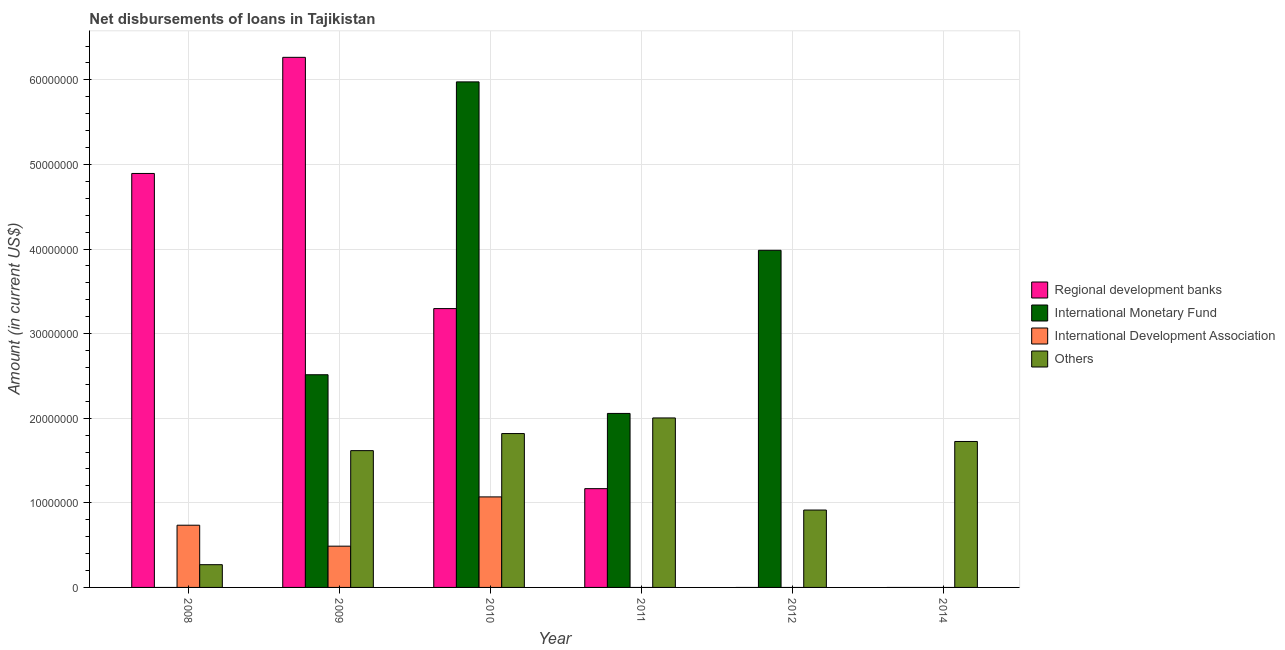How many bars are there on the 3rd tick from the left?
Your answer should be compact. 4. In how many cases, is the number of bars for a given year not equal to the number of legend labels?
Your response must be concise. 4. What is the amount of loan disimbursed by international development association in 2009?
Keep it short and to the point. 4.88e+06. Across all years, what is the maximum amount of loan disimbursed by other organisations?
Give a very brief answer. 2.00e+07. Across all years, what is the minimum amount of loan disimbursed by regional development banks?
Make the answer very short. 0. What is the total amount of loan disimbursed by international monetary fund in the graph?
Your answer should be very brief. 1.45e+08. What is the difference between the amount of loan disimbursed by international development association in 2008 and that in 2009?
Give a very brief answer. 2.48e+06. What is the difference between the amount of loan disimbursed by international monetary fund in 2008 and the amount of loan disimbursed by other organisations in 2011?
Provide a succinct answer. -2.06e+07. What is the average amount of loan disimbursed by regional development banks per year?
Your answer should be very brief. 2.60e+07. What is the ratio of the amount of loan disimbursed by international development association in 2008 to that in 2009?
Offer a terse response. 1.51. Is the difference between the amount of loan disimbursed by other organisations in 2009 and 2014 greater than the difference between the amount of loan disimbursed by regional development banks in 2009 and 2014?
Provide a short and direct response. No. What is the difference between the highest and the second highest amount of loan disimbursed by international monetary fund?
Provide a short and direct response. 1.99e+07. What is the difference between the highest and the lowest amount of loan disimbursed by international development association?
Provide a succinct answer. 1.07e+07. How many years are there in the graph?
Ensure brevity in your answer.  6. Are the values on the major ticks of Y-axis written in scientific E-notation?
Make the answer very short. No. Does the graph contain any zero values?
Offer a terse response. Yes. How are the legend labels stacked?
Give a very brief answer. Vertical. What is the title of the graph?
Offer a terse response. Net disbursements of loans in Tajikistan. Does "Environmental sustainability" appear as one of the legend labels in the graph?
Your answer should be very brief. No. What is the label or title of the X-axis?
Provide a short and direct response. Year. What is the label or title of the Y-axis?
Keep it short and to the point. Amount (in current US$). What is the Amount (in current US$) in Regional development banks in 2008?
Offer a very short reply. 4.89e+07. What is the Amount (in current US$) in International Monetary Fund in 2008?
Offer a terse response. 0. What is the Amount (in current US$) of International Development Association in 2008?
Your answer should be very brief. 7.35e+06. What is the Amount (in current US$) of Others in 2008?
Ensure brevity in your answer.  2.69e+06. What is the Amount (in current US$) of Regional development banks in 2009?
Your answer should be very brief. 6.27e+07. What is the Amount (in current US$) of International Monetary Fund in 2009?
Provide a succinct answer. 2.51e+07. What is the Amount (in current US$) in International Development Association in 2009?
Your answer should be very brief. 4.88e+06. What is the Amount (in current US$) of Others in 2009?
Give a very brief answer. 1.62e+07. What is the Amount (in current US$) of Regional development banks in 2010?
Make the answer very short. 3.30e+07. What is the Amount (in current US$) of International Monetary Fund in 2010?
Give a very brief answer. 5.98e+07. What is the Amount (in current US$) in International Development Association in 2010?
Offer a very short reply. 1.07e+07. What is the Amount (in current US$) in Others in 2010?
Give a very brief answer. 1.82e+07. What is the Amount (in current US$) in Regional development banks in 2011?
Provide a short and direct response. 1.17e+07. What is the Amount (in current US$) of International Monetary Fund in 2011?
Your answer should be compact. 2.06e+07. What is the Amount (in current US$) in International Development Association in 2011?
Keep it short and to the point. 0. What is the Amount (in current US$) of Others in 2011?
Make the answer very short. 2.00e+07. What is the Amount (in current US$) of International Monetary Fund in 2012?
Ensure brevity in your answer.  3.99e+07. What is the Amount (in current US$) in International Development Association in 2012?
Offer a very short reply. 0. What is the Amount (in current US$) of Others in 2012?
Your answer should be very brief. 9.15e+06. What is the Amount (in current US$) of International Monetary Fund in 2014?
Provide a short and direct response. 0. What is the Amount (in current US$) in Others in 2014?
Make the answer very short. 1.73e+07. Across all years, what is the maximum Amount (in current US$) of Regional development banks?
Offer a very short reply. 6.27e+07. Across all years, what is the maximum Amount (in current US$) of International Monetary Fund?
Your answer should be very brief. 5.98e+07. Across all years, what is the maximum Amount (in current US$) in International Development Association?
Keep it short and to the point. 1.07e+07. Across all years, what is the maximum Amount (in current US$) of Others?
Ensure brevity in your answer.  2.00e+07. Across all years, what is the minimum Amount (in current US$) in Regional development banks?
Make the answer very short. 0. Across all years, what is the minimum Amount (in current US$) of Others?
Your answer should be compact. 2.69e+06. What is the total Amount (in current US$) of Regional development banks in the graph?
Your answer should be compact. 1.56e+08. What is the total Amount (in current US$) of International Monetary Fund in the graph?
Make the answer very short. 1.45e+08. What is the total Amount (in current US$) in International Development Association in the graph?
Your response must be concise. 2.29e+07. What is the total Amount (in current US$) in Others in the graph?
Give a very brief answer. 8.35e+07. What is the difference between the Amount (in current US$) in Regional development banks in 2008 and that in 2009?
Ensure brevity in your answer.  -1.37e+07. What is the difference between the Amount (in current US$) in International Development Association in 2008 and that in 2009?
Your response must be concise. 2.48e+06. What is the difference between the Amount (in current US$) in Others in 2008 and that in 2009?
Offer a terse response. -1.35e+07. What is the difference between the Amount (in current US$) in Regional development banks in 2008 and that in 2010?
Make the answer very short. 1.60e+07. What is the difference between the Amount (in current US$) in International Development Association in 2008 and that in 2010?
Ensure brevity in your answer.  -3.35e+06. What is the difference between the Amount (in current US$) in Others in 2008 and that in 2010?
Your answer should be compact. -1.55e+07. What is the difference between the Amount (in current US$) in Regional development banks in 2008 and that in 2011?
Give a very brief answer. 3.73e+07. What is the difference between the Amount (in current US$) of Others in 2008 and that in 2011?
Offer a very short reply. -1.73e+07. What is the difference between the Amount (in current US$) in Others in 2008 and that in 2012?
Your answer should be very brief. -6.46e+06. What is the difference between the Amount (in current US$) of Others in 2008 and that in 2014?
Your answer should be very brief. -1.46e+07. What is the difference between the Amount (in current US$) in Regional development banks in 2009 and that in 2010?
Offer a terse response. 2.97e+07. What is the difference between the Amount (in current US$) of International Monetary Fund in 2009 and that in 2010?
Your answer should be very brief. -3.46e+07. What is the difference between the Amount (in current US$) in International Development Association in 2009 and that in 2010?
Your response must be concise. -5.82e+06. What is the difference between the Amount (in current US$) of Others in 2009 and that in 2010?
Your response must be concise. -2.02e+06. What is the difference between the Amount (in current US$) in Regional development banks in 2009 and that in 2011?
Your answer should be compact. 5.10e+07. What is the difference between the Amount (in current US$) of International Monetary Fund in 2009 and that in 2011?
Give a very brief answer. 4.57e+06. What is the difference between the Amount (in current US$) in Others in 2009 and that in 2011?
Offer a terse response. -3.86e+06. What is the difference between the Amount (in current US$) of International Monetary Fund in 2009 and that in 2012?
Make the answer very short. -1.47e+07. What is the difference between the Amount (in current US$) in Others in 2009 and that in 2012?
Offer a very short reply. 7.02e+06. What is the difference between the Amount (in current US$) of Others in 2009 and that in 2014?
Provide a succinct answer. -1.08e+06. What is the difference between the Amount (in current US$) of Regional development banks in 2010 and that in 2011?
Keep it short and to the point. 2.13e+07. What is the difference between the Amount (in current US$) in International Monetary Fund in 2010 and that in 2011?
Keep it short and to the point. 3.92e+07. What is the difference between the Amount (in current US$) of Others in 2010 and that in 2011?
Provide a short and direct response. -1.84e+06. What is the difference between the Amount (in current US$) in International Monetary Fund in 2010 and that in 2012?
Ensure brevity in your answer.  1.99e+07. What is the difference between the Amount (in current US$) in Others in 2010 and that in 2012?
Offer a terse response. 9.04e+06. What is the difference between the Amount (in current US$) of Others in 2010 and that in 2014?
Offer a terse response. 9.37e+05. What is the difference between the Amount (in current US$) in International Monetary Fund in 2011 and that in 2012?
Provide a short and direct response. -1.93e+07. What is the difference between the Amount (in current US$) of Others in 2011 and that in 2012?
Make the answer very short. 1.09e+07. What is the difference between the Amount (in current US$) of Others in 2011 and that in 2014?
Provide a succinct answer. 2.78e+06. What is the difference between the Amount (in current US$) in Others in 2012 and that in 2014?
Ensure brevity in your answer.  -8.10e+06. What is the difference between the Amount (in current US$) of Regional development banks in 2008 and the Amount (in current US$) of International Monetary Fund in 2009?
Provide a succinct answer. 2.38e+07. What is the difference between the Amount (in current US$) of Regional development banks in 2008 and the Amount (in current US$) of International Development Association in 2009?
Offer a terse response. 4.41e+07. What is the difference between the Amount (in current US$) of Regional development banks in 2008 and the Amount (in current US$) of Others in 2009?
Offer a terse response. 3.28e+07. What is the difference between the Amount (in current US$) in International Development Association in 2008 and the Amount (in current US$) in Others in 2009?
Offer a very short reply. -8.82e+06. What is the difference between the Amount (in current US$) in Regional development banks in 2008 and the Amount (in current US$) in International Monetary Fund in 2010?
Keep it short and to the point. -1.08e+07. What is the difference between the Amount (in current US$) in Regional development banks in 2008 and the Amount (in current US$) in International Development Association in 2010?
Your answer should be very brief. 3.82e+07. What is the difference between the Amount (in current US$) in Regional development banks in 2008 and the Amount (in current US$) in Others in 2010?
Keep it short and to the point. 3.07e+07. What is the difference between the Amount (in current US$) in International Development Association in 2008 and the Amount (in current US$) in Others in 2010?
Offer a terse response. -1.08e+07. What is the difference between the Amount (in current US$) of Regional development banks in 2008 and the Amount (in current US$) of International Monetary Fund in 2011?
Provide a succinct answer. 2.84e+07. What is the difference between the Amount (in current US$) in Regional development banks in 2008 and the Amount (in current US$) in Others in 2011?
Make the answer very short. 2.89e+07. What is the difference between the Amount (in current US$) in International Development Association in 2008 and the Amount (in current US$) in Others in 2011?
Keep it short and to the point. -1.27e+07. What is the difference between the Amount (in current US$) of Regional development banks in 2008 and the Amount (in current US$) of International Monetary Fund in 2012?
Ensure brevity in your answer.  9.08e+06. What is the difference between the Amount (in current US$) of Regional development banks in 2008 and the Amount (in current US$) of Others in 2012?
Ensure brevity in your answer.  3.98e+07. What is the difference between the Amount (in current US$) of International Development Association in 2008 and the Amount (in current US$) of Others in 2012?
Keep it short and to the point. -1.80e+06. What is the difference between the Amount (in current US$) in Regional development banks in 2008 and the Amount (in current US$) in Others in 2014?
Provide a short and direct response. 3.17e+07. What is the difference between the Amount (in current US$) of International Development Association in 2008 and the Amount (in current US$) of Others in 2014?
Offer a terse response. -9.90e+06. What is the difference between the Amount (in current US$) of Regional development banks in 2009 and the Amount (in current US$) of International Monetary Fund in 2010?
Your answer should be very brief. 2.90e+06. What is the difference between the Amount (in current US$) in Regional development banks in 2009 and the Amount (in current US$) in International Development Association in 2010?
Keep it short and to the point. 5.20e+07. What is the difference between the Amount (in current US$) in Regional development banks in 2009 and the Amount (in current US$) in Others in 2010?
Provide a short and direct response. 4.45e+07. What is the difference between the Amount (in current US$) of International Monetary Fund in 2009 and the Amount (in current US$) of International Development Association in 2010?
Ensure brevity in your answer.  1.44e+07. What is the difference between the Amount (in current US$) of International Monetary Fund in 2009 and the Amount (in current US$) of Others in 2010?
Your answer should be compact. 6.95e+06. What is the difference between the Amount (in current US$) of International Development Association in 2009 and the Amount (in current US$) of Others in 2010?
Your response must be concise. -1.33e+07. What is the difference between the Amount (in current US$) of Regional development banks in 2009 and the Amount (in current US$) of International Monetary Fund in 2011?
Keep it short and to the point. 4.21e+07. What is the difference between the Amount (in current US$) in Regional development banks in 2009 and the Amount (in current US$) in Others in 2011?
Your answer should be very brief. 4.26e+07. What is the difference between the Amount (in current US$) in International Monetary Fund in 2009 and the Amount (in current US$) in Others in 2011?
Offer a terse response. 5.11e+06. What is the difference between the Amount (in current US$) in International Development Association in 2009 and the Amount (in current US$) in Others in 2011?
Ensure brevity in your answer.  -1.52e+07. What is the difference between the Amount (in current US$) of Regional development banks in 2009 and the Amount (in current US$) of International Monetary Fund in 2012?
Provide a short and direct response. 2.28e+07. What is the difference between the Amount (in current US$) in Regional development banks in 2009 and the Amount (in current US$) in Others in 2012?
Your response must be concise. 5.35e+07. What is the difference between the Amount (in current US$) in International Monetary Fund in 2009 and the Amount (in current US$) in Others in 2012?
Your answer should be compact. 1.60e+07. What is the difference between the Amount (in current US$) of International Development Association in 2009 and the Amount (in current US$) of Others in 2012?
Your response must be concise. -4.27e+06. What is the difference between the Amount (in current US$) of Regional development banks in 2009 and the Amount (in current US$) of Others in 2014?
Offer a terse response. 4.54e+07. What is the difference between the Amount (in current US$) in International Monetary Fund in 2009 and the Amount (in current US$) in Others in 2014?
Offer a terse response. 7.89e+06. What is the difference between the Amount (in current US$) in International Development Association in 2009 and the Amount (in current US$) in Others in 2014?
Provide a succinct answer. -1.24e+07. What is the difference between the Amount (in current US$) in Regional development banks in 2010 and the Amount (in current US$) in International Monetary Fund in 2011?
Your response must be concise. 1.24e+07. What is the difference between the Amount (in current US$) of Regional development banks in 2010 and the Amount (in current US$) of Others in 2011?
Your answer should be very brief. 1.29e+07. What is the difference between the Amount (in current US$) in International Monetary Fund in 2010 and the Amount (in current US$) in Others in 2011?
Make the answer very short. 3.97e+07. What is the difference between the Amount (in current US$) in International Development Association in 2010 and the Amount (in current US$) in Others in 2011?
Your answer should be compact. -9.33e+06. What is the difference between the Amount (in current US$) in Regional development banks in 2010 and the Amount (in current US$) in International Monetary Fund in 2012?
Offer a terse response. -6.89e+06. What is the difference between the Amount (in current US$) of Regional development banks in 2010 and the Amount (in current US$) of Others in 2012?
Provide a short and direct response. 2.38e+07. What is the difference between the Amount (in current US$) of International Monetary Fund in 2010 and the Amount (in current US$) of Others in 2012?
Provide a short and direct response. 5.06e+07. What is the difference between the Amount (in current US$) of International Development Association in 2010 and the Amount (in current US$) of Others in 2012?
Your answer should be very brief. 1.55e+06. What is the difference between the Amount (in current US$) in Regional development banks in 2010 and the Amount (in current US$) in Others in 2014?
Your response must be concise. 1.57e+07. What is the difference between the Amount (in current US$) of International Monetary Fund in 2010 and the Amount (in current US$) of Others in 2014?
Your answer should be compact. 4.25e+07. What is the difference between the Amount (in current US$) of International Development Association in 2010 and the Amount (in current US$) of Others in 2014?
Your response must be concise. -6.55e+06. What is the difference between the Amount (in current US$) of Regional development banks in 2011 and the Amount (in current US$) of International Monetary Fund in 2012?
Your response must be concise. -2.82e+07. What is the difference between the Amount (in current US$) in Regional development banks in 2011 and the Amount (in current US$) in Others in 2012?
Give a very brief answer. 2.53e+06. What is the difference between the Amount (in current US$) in International Monetary Fund in 2011 and the Amount (in current US$) in Others in 2012?
Your answer should be compact. 1.14e+07. What is the difference between the Amount (in current US$) in Regional development banks in 2011 and the Amount (in current US$) in Others in 2014?
Give a very brief answer. -5.58e+06. What is the difference between the Amount (in current US$) of International Monetary Fund in 2011 and the Amount (in current US$) of Others in 2014?
Keep it short and to the point. 3.32e+06. What is the difference between the Amount (in current US$) in International Monetary Fund in 2012 and the Amount (in current US$) in Others in 2014?
Give a very brief answer. 2.26e+07. What is the average Amount (in current US$) of Regional development banks per year?
Ensure brevity in your answer.  2.60e+07. What is the average Amount (in current US$) in International Monetary Fund per year?
Ensure brevity in your answer.  2.42e+07. What is the average Amount (in current US$) in International Development Association per year?
Give a very brief answer. 3.82e+06. What is the average Amount (in current US$) of Others per year?
Ensure brevity in your answer.  1.39e+07. In the year 2008, what is the difference between the Amount (in current US$) of Regional development banks and Amount (in current US$) of International Development Association?
Provide a succinct answer. 4.16e+07. In the year 2008, what is the difference between the Amount (in current US$) in Regional development banks and Amount (in current US$) in Others?
Your answer should be compact. 4.62e+07. In the year 2008, what is the difference between the Amount (in current US$) of International Development Association and Amount (in current US$) of Others?
Keep it short and to the point. 4.66e+06. In the year 2009, what is the difference between the Amount (in current US$) of Regional development banks and Amount (in current US$) of International Monetary Fund?
Make the answer very short. 3.75e+07. In the year 2009, what is the difference between the Amount (in current US$) of Regional development banks and Amount (in current US$) of International Development Association?
Ensure brevity in your answer.  5.78e+07. In the year 2009, what is the difference between the Amount (in current US$) of Regional development banks and Amount (in current US$) of Others?
Make the answer very short. 4.65e+07. In the year 2009, what is the difference between the Amount (in current US$) in International Monetary Fund and Amount (in current US$) in International Development Association?
Give a very brief answer. 2.03e+07. In the year 2009, what is the difference between the Amount (in current US$) in International Monetary Fund and Amount (in current US$) in Others?
Your answer should be very brief. 8.97e+06. In the year 2009, what is the difference between the Amount (in current US$) in International Development Association and Amount (in current US$) in Others?
Keep it short and to the point. -1.13e+07. In the year 2010, what is the difference between the Amount (in current US$) in Regional development banks and Amount (in current US$) in International Monetary Fund?
Ensure brevity in your answer.  -2.68e+07. In the year 2010, what is the difference between the Amount (in current US$) in Regional development banks and Amount (in current US$) in International Development Association?
Give a very brief answer. 2.23e+07. In the year 2010, what is the difference between the Amount (in current US$) in Regional development banks and Amount (in current US$) in Others?
Give a very brief answer. 1.48e+07. In the year 2010, what is the difference between the Amount (in current US$) in International Monetary Fund and Amount (in current US$) in International Development Association?
Make the answer very short. 4.91e+07. In the year 2010, what is the difference between the Amount (in current US$) in International Monetary Fund and Amount (in current US$) in Others?
Provide a short and direct response. 4.16e+07. In the year 2010, what is the difference between the Amount (in current US$) of International Development Association and Amount (in current US$) of Others?
Offer a very short reply. -7.49e+06. In the year 2011, what is the difference between the Amount (in current US$) of Regional development banks and Amount (in current US$) of International Monetary Fund?
Your answer should be very brief. -8.89e+06. In the year 2011, what is the difference between the Amount (in current US$) in Regional development banks and Amount (in current US$) in Others?
Offer a terse response. -8.36e+06. In the year 2011, what is the difference between the Amount (in current US$) in International Monetary Fund and Amount (in current US$) in Others?
Provide a succinct answer. 5.33e+05. In the year 2012, what is the difference between the Amount (in current US$) of International Monetary Fund and Amount (in current US$) of Others?
Your answer should be compact. 3.07e+07. What is the ratio of the Amount (in current US$) of Regional development banks in 2008 to that in 2009?
Your answer should be compact. 0.78. What is the ratio of the Amount (in current US$) in International Development Association in 2008 to that in 2009?
Provide a succinct answer. 1.51. What is the ratio of the Amount (in current US$) of Others in 2008 to that in 2009?
Provide a short and direct response. 0.17. What is the ratio of the Amount (in current US$) of Regional development banks in 2008 to that in 2010?
Your response must be concise. 1.48. What is the ratio of the Amount (in current US$) of International Development Association in 2008 to that in 2010?
Give a very brief answer. 0.69. What is the ratio of the Amount (in current US$) in Others in 2008 to that in 2010?
Keep it short and to the point. 0.15. What is the ratio of the Amount (in current US$) in Regional development banks in 2008 to that in 2011?
Give a very brief answer. 4.19. What is the ratio of the Amount (in current US$) of Others in 2008 to that in 2011?
Offer a terse response. 0.13. What is the ratio of the Amount (in current US$) of Others in 2008 to that in 2012?
Offer a very short reply. 0.29. What is the ratio of the Amount (in current US$) in Others in 2008 to that in 2014?
Your answer should be compact. 0.16. What is the ratio of the Amount (in current US$) of Regional development banks in 2009 to that in 2010?
Make the answer very short. 1.9. What is the ratio of the Amount (in current US$) of International Monetary Fund in 2009 to that in 2010?
Your answer should be very brief. 0.42. What is the ratio of the Amount (in current US$) in International Development Association in 2009 to that in 2010?
Provide a short and direct response. 0.46. What is the ratio of the Amount (in current US$) in Others in 2009 to that in 2010?
Keep it short and to the point. 0.89. What is the ratio of the Amount (in current US$) of Regional development banks in 2009 to that in 2011?
Provide a short and direct response. 5.37. What is the ratio of the Amount (in current US$) in International Monetary Fund in 2009 to that in 2011?
Your response must be concise. 1.22. What is the ratio of the Amount (in current US$) in Others in 2009 to that in 2011?
Provide a succinct answer. 0.81. What is the ratio of the Amount (in current US$) of International Monetary Fund in 2009 to that in 2012?
Provide a short and direct response. 0.63. What is the ratio of the Amount (in current US$) of Others in 2009 to that in 2012?
Offer a terse response. 1.77. What is the ratio of the Amount (in current US$) in Others in 2009 to that in 2014?
Provide a succinct answer. 0.94. What is the ratio of the Amount (in current US$) in Regional development banks in 2010 to that in 2011?
Give a very brief answer. 2.82. What is the ratio of the Amount (in current US$) in International Monetary Fund in 2010 to that in 2011?
Ensure brevity in your answer.  2.91. What is the ratio of the Amount (in current US$) of Others in 2010 to that in 2011?
Keep it short and to the point. 0.91. What is the ratio of the Amount (in current US$) in International Monetary Fund in 2010 to that in 2012?
Your response must be concise. 1.5. What is the ratio of the Amount (in current US$) in Others in 2010 to that in 2012?
Keep it short and to the point. 1.99. What is the ratio of the Amount (in current US$) of Others in 2010 to that in 2014?
Offer a terse response. 1.05. What is the ratio of the Amount (in current US$) of International Monetary Fund in 2011 to that in 2012?
Your response must be concise. 0.52. What is the ratio of the Amount (in current US$) in Others in 2011 to that in 2012?
Your answer should be very brief. 2.19. What is the ratio of the Amount (in current US$) in Others in 2011 to that in 2014?
Your response must be concise. 1.16. What is the ratio of the Amount (in current US$) of Others in 2012 to that in 2014?
Provide a succinct answer. 0.53. What is the difference between the highest and the second highest Amount (in current US$) in Regional development banks?
Make the answer very short. 1.37e+07. What is the difference between the highest and the second highest Amount (in current US$) in International Monetary Fund?
Provide a short and direct response. 1.99e+07. What is the difference between the highest and the second highest Amount (in current US$) in International Development Association?
Offer a very short reply. 3.35e+06. What is the difference between the highest and the second highest Amount (in current US$) of Others?
Offer a terse response. 1.84e+06. What is the difference between the highest and the lowest Amount (in current US$) in Regional development banks?
Provide a succinct answer. 6.27e+07. What is the difference between the highest and the lowest Amount (in current US$) of International Monetary Fund?
Offer a terse response. 5.98e+07. What is the difference between the highest and the lowest Amount (in current US$) in International Development Association?
Keep it short and to the point. 1.07e+07. What is the difference between the highest and the lowest Amount (in current US$) of Others?
Offer a terse response. 1.73e+07. 